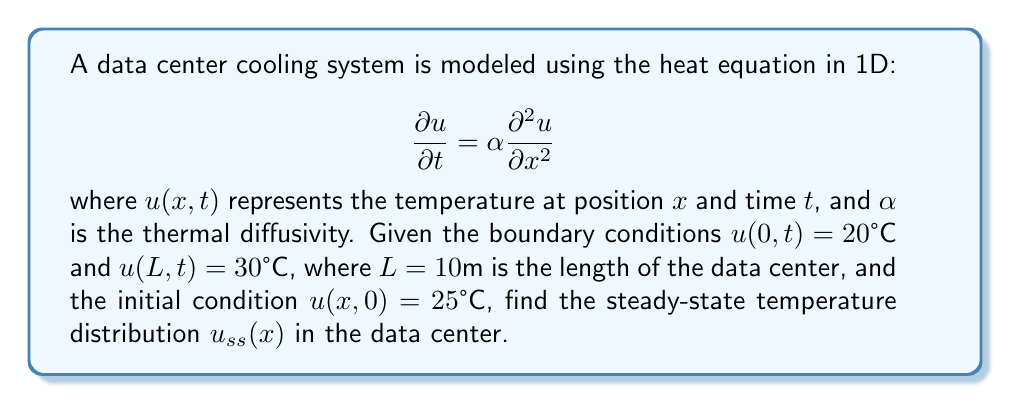What is the answer to this math problem? To solve this problem, we need to follow these steps:

1) For the steady-state solution, the temperature doesn't change with time, so $\frac{\partial u}{\partial t} = 0$. The heat equation reduces to:

   $$0 = \alpha \frac{d^2 u_{ss}}{dx^2}$$

2) Integrating twice with respect to $x$:

   $$u_{ss}(x) = Ax + B$$

   where $A$ and $B$ are constants to be determined from the boundary conditions.

3) Apply the boundary conditions:

   At $x=0$: $u_{ss}(0) = B = 20°C$
   At $x=L$: $u_{ss}(L) = AL + B = 30°C$

4) Substituting the known values:

   $30 = A(10) + 20$
   $A = 1°C/m$

5) Therefore, the steady-state temperature distribution is:

   $$u_{ss}(x) = x + 20$$

This linear distribution satisfies the boundary conditions and represents the equilibrium state of the system.

From an IT perspective, this solution helps in understanding the temperature gradient across the data center, which is crucial for optimal placement of servers and cooling equipment.
Answer: The steady-state temperature distribution in the data center is:

$$u_{ss}(x) = x + 20°C$$

where $x$ is the distance in meters from the cooler end of the data center. 